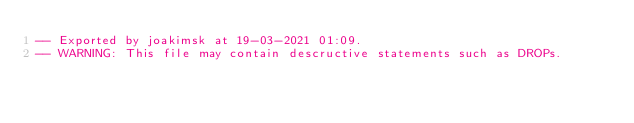<code> <loc_0><loc_0><loc_500><loc_500><_SQL_>-- Exported by joakimsk at 19-03-2021 01:09.
-- WARNING: This file may contain descructive statements such as DROPs.</code> 